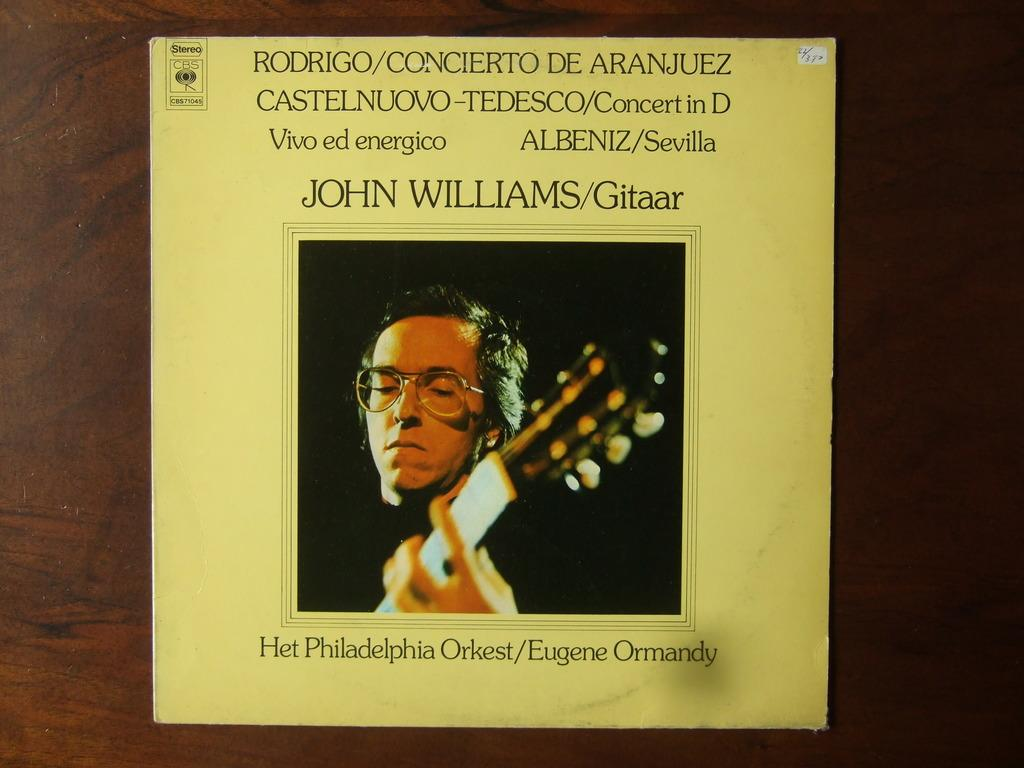<image>
Describe the image concisely. The cover of an album by John Williams indicates that it features the Philadelphia Orkest. 